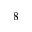Convert formula to latex. <formula><loc_0><loc_0><loc_500><loc_500>8</formula> 